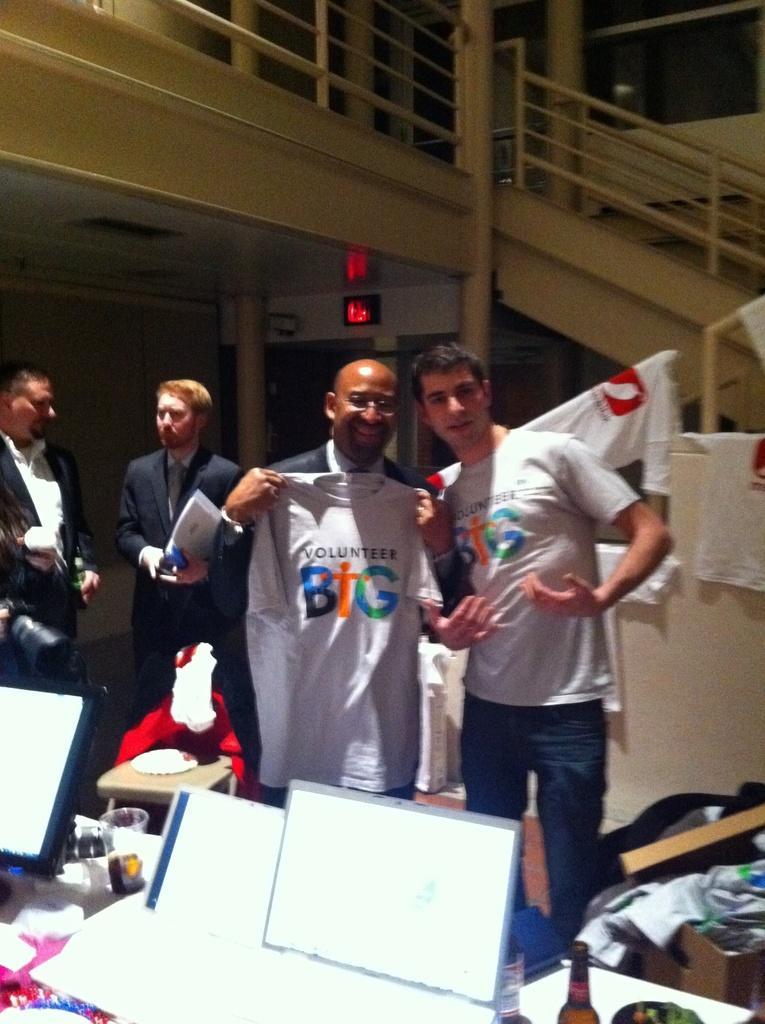How would you summarize this image in a sentence or two? In this picture I can see four persons standing. There is a person holding a t-shirt. There is a monitor, laptop, stool, table, bottle, glass, cardboard box and some other objects, and in the background there are stairs, staircase holders and t-shirts. 